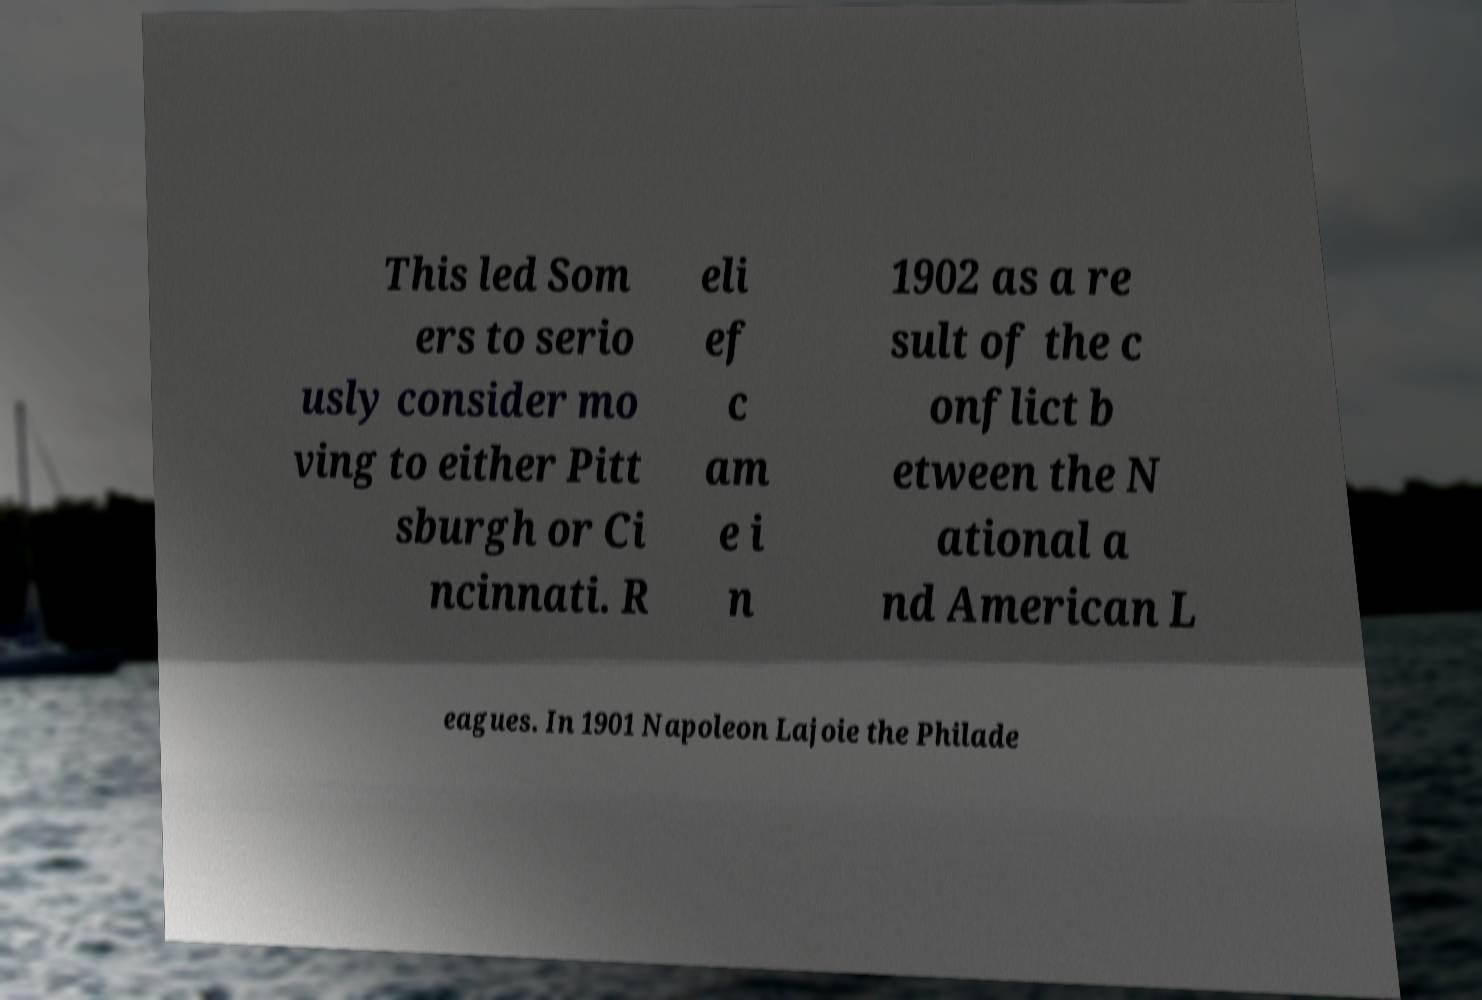Can you read and provide the text displayed in the image?This photo seems to have some interesting text. Can you extract and type it out for me? This led Som ers to serio usly consider mo ving to either Pitt sburgh or Ci ncinnati. R eli ef c am e i n 1902 as a re sult of the c onflict b etween the N ational a nd American L eagues. In 1901 Napoleon Lajoie the Philade 